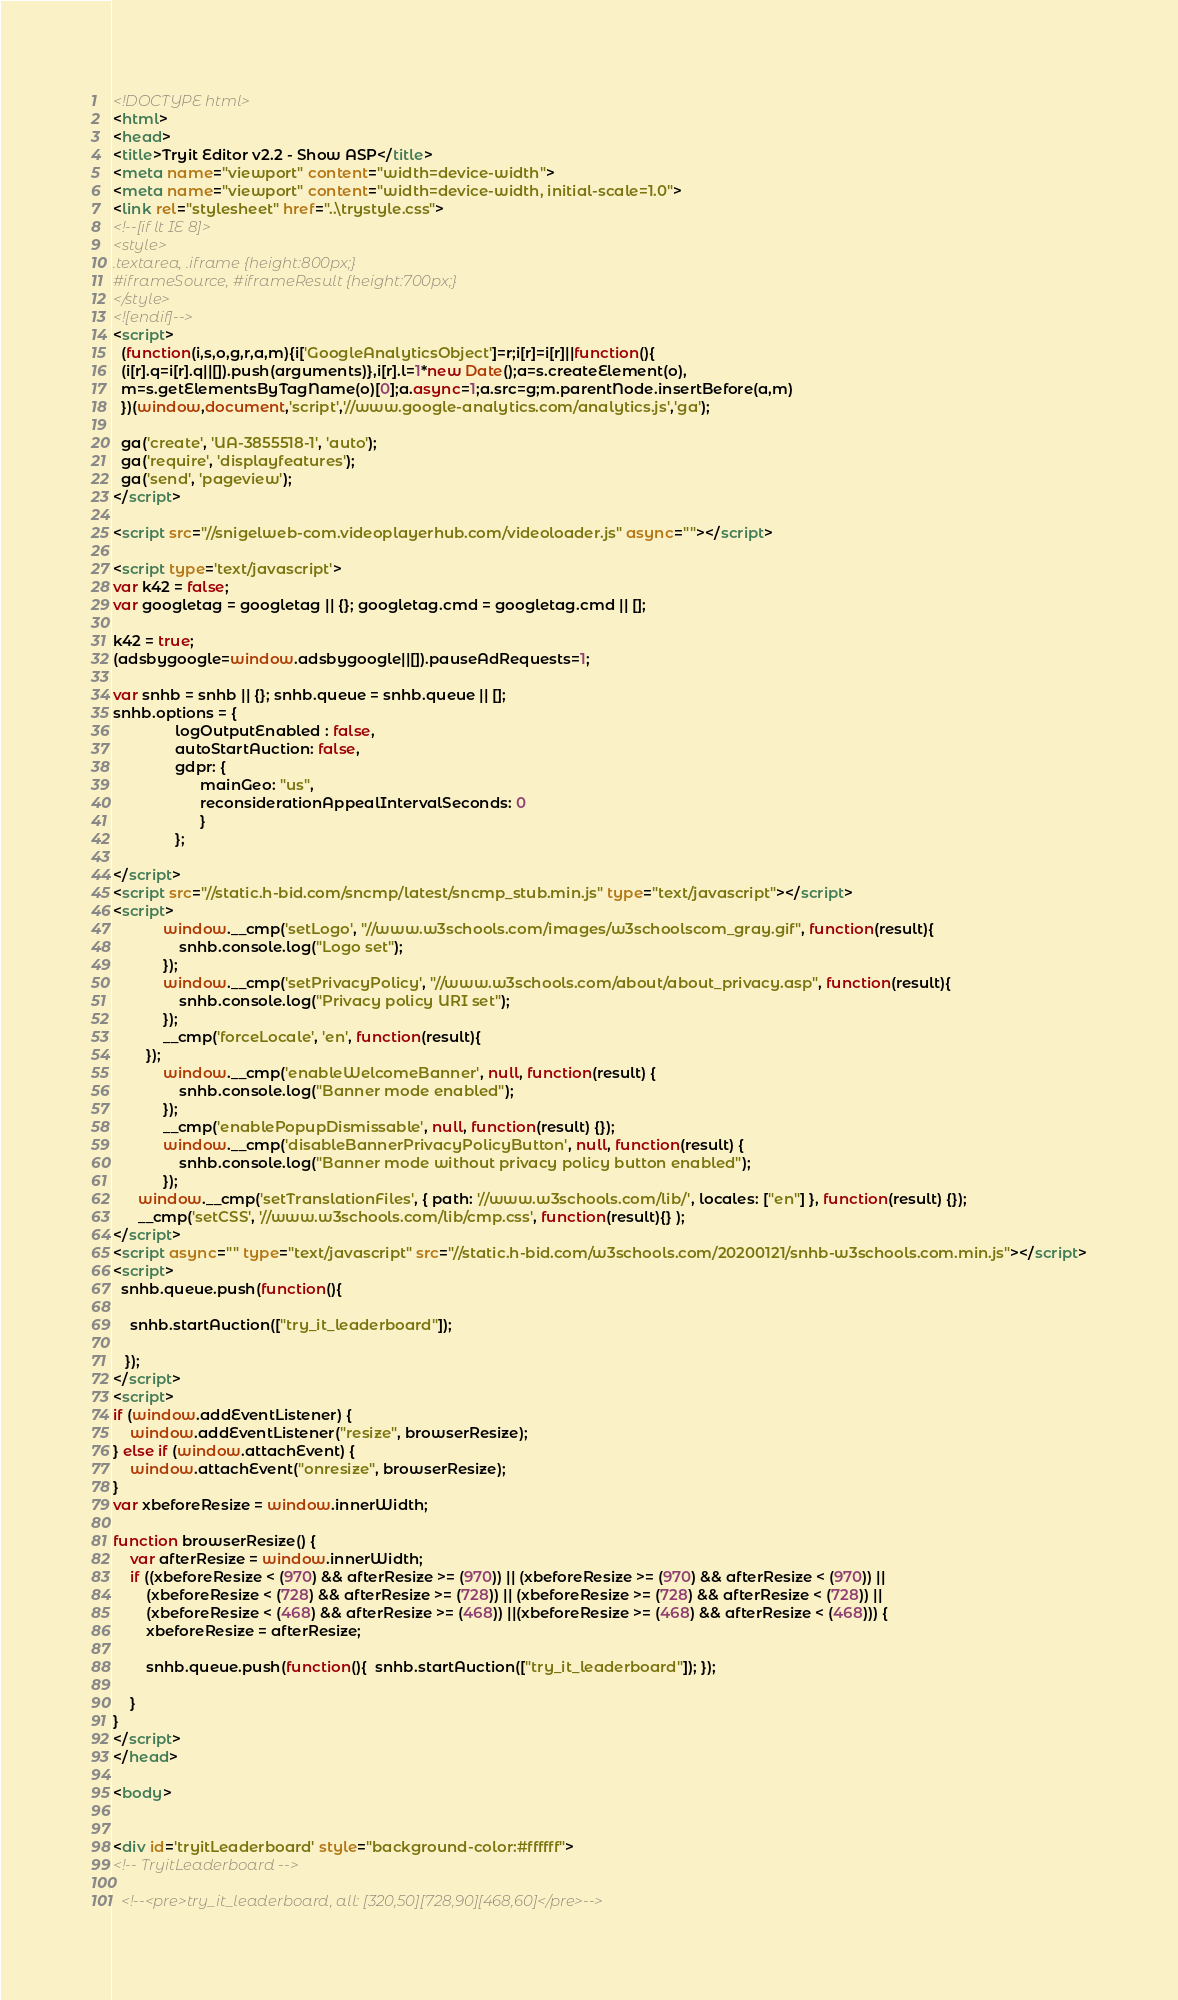<code> <loc_0><loc_0><loc_500><loc_500><_HTML_>
<!DOCTYPE html>
<html>
<head>
<title>Tryit Editor v2.2 - Show ASP</title>
<meta name="viewport" content="width=device-width">
<meta name="viewport" content="width=device-width, initial-scale=1.0">
<link rel="stylesheet" href="..\trystyle.css">
<!--[if lt IE 8]>
<style>
.textarea, .iframe {height:800px;}
#iframeSource, #iframeResult {height:700px;}
</style>
<![endif]-->
<script>
  (function(i,s,o,g,r,a,m){i['GoogleAnalyticsObject']=r;i[r]=i[r]||function(){
  (i[r].q=i[r].q||[]).push(arguments)},i[r].l=1*new Date();a=s.createElement(o),
  m=s.getElementsByTagName(o)[0];a.async=1;a.src=g;m.parentNode.insertBefore(a,m)
  })(window,document,'script','//www.google-analytics.com/analytics.js','ga');

  ga('create', 'UA-3855518-1', 'auto');
  ga('require', 'displayfeatures');
  ga('send', 'pageview');
</script>

<script src="//snigelweb-com.videoplayerhub.com/videoloader.js" async=""></script>

<script type='text/javascript'>
var k42 = false;
var googletag = googletag || {}; googletag.cmd = googletag.cmd || [];

k42 = true;
(adsbygoogle=window.adsbygoogle||[]).pauseAdRequests=1;

var snhb = snhb || {}; snhb.queue = snhb.queue || [];
snhb.options = {
               logOutputEnabled : false,
               autoStartAuction: false,
               gdpr: {
                     mainGeo: "us",
                     reconsiderationAppealIntervalSeconds: 0
                     }
               };

</script>
<script src="//static.h-bid.com/sncmp/latest/sncmp_stub.min.js" type="text/javascript"></script>
<script>
			window.__cmp('setLogo', "//www.w3schools.com/images/w3schoolscom_gray.gif", function(result){
	       		snhb.console.log("Logo set");
	    	});
			window.__cmp('setPrivacyPolicy', "//www.w3schools.com/about/about_privacy.asp", function(result){
	       		snhb.console.log("Privacy policy URI set");
	    	});
			__cmp('forceLocale', 'en', function(result){
	    });
			window.__cmp('enableWelcomeBanner', null, function(result) {
	       		snhb.console.log("Banner mode enabled");
			});
			__cmp('enablePopupDismissable', null, function(result) {});
			window.__cmp('disableBannerPrivacyPolicyButton', null, function(result) {
	       		snhb.console.log("Banner mode without privacy policy button enabled");
			});
      window.__cmp('setTranslationFiles', { path: '//www.w3schools.com/lib/', locales: ["en"] }, function(result) {});
      __cmp('setCSS', '//www.w3schools.com/lib/cmp.css', function(result){} );
</script>
<script async="" type="text/javascript" src="//static.h-bid.com/w3schools.com/20200121/snhb-w3schools.com.min.js"></script>
<script>
  snhb.queue.push(function(){

    snhb.startAuction(["try_it_leaderboard"]);

   });
</script>
<script>
if (window.addEventListener) {              
    window.addEventListener("resize", browserResize);
} else if (window.attachEvent) {                 
    window.attachEvent("onresize", browserResize);
}
var xbeforeResize = window.innerWidth;

function browserResize() {
    var afterResize = window.innerWidth;
    if ((xbeforeResize < (970) && afterResize >= (970)) || (xbeforeResize >= (970) && afterResize < (970)) ||
        (xbeforeResize < (728) && afterResize >= (728)) || (xbeforeResize >= (728) && afterResize < (728)) ||
        (xbeforeResize < (468) && afterResize >= (468)) ||(xbeforeResize >= (468) && afterResize < (468))) {
        xbeforeResize = afterResize;
        
        snhb.queue.push(function(){  snhb.startAuction(["try_it_leaderboard"]); });
         
    }
}
</script>
</head>

<body>


<div id='tryitLeaderboard' style="background-color:#ffffff">
<!-- TryitLeaderboard -->

  <!--<pre>try_it_leaderboard, all: [320,50][728,90][468,60]</pre>--></code> 